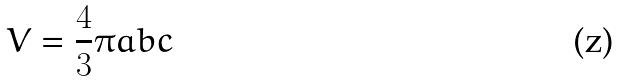Convert formula to latex. <formula><loc_0><loc_0><loc_500><loc_500>V = \frac { 4 } { 3 } \pi a b c</formula> 